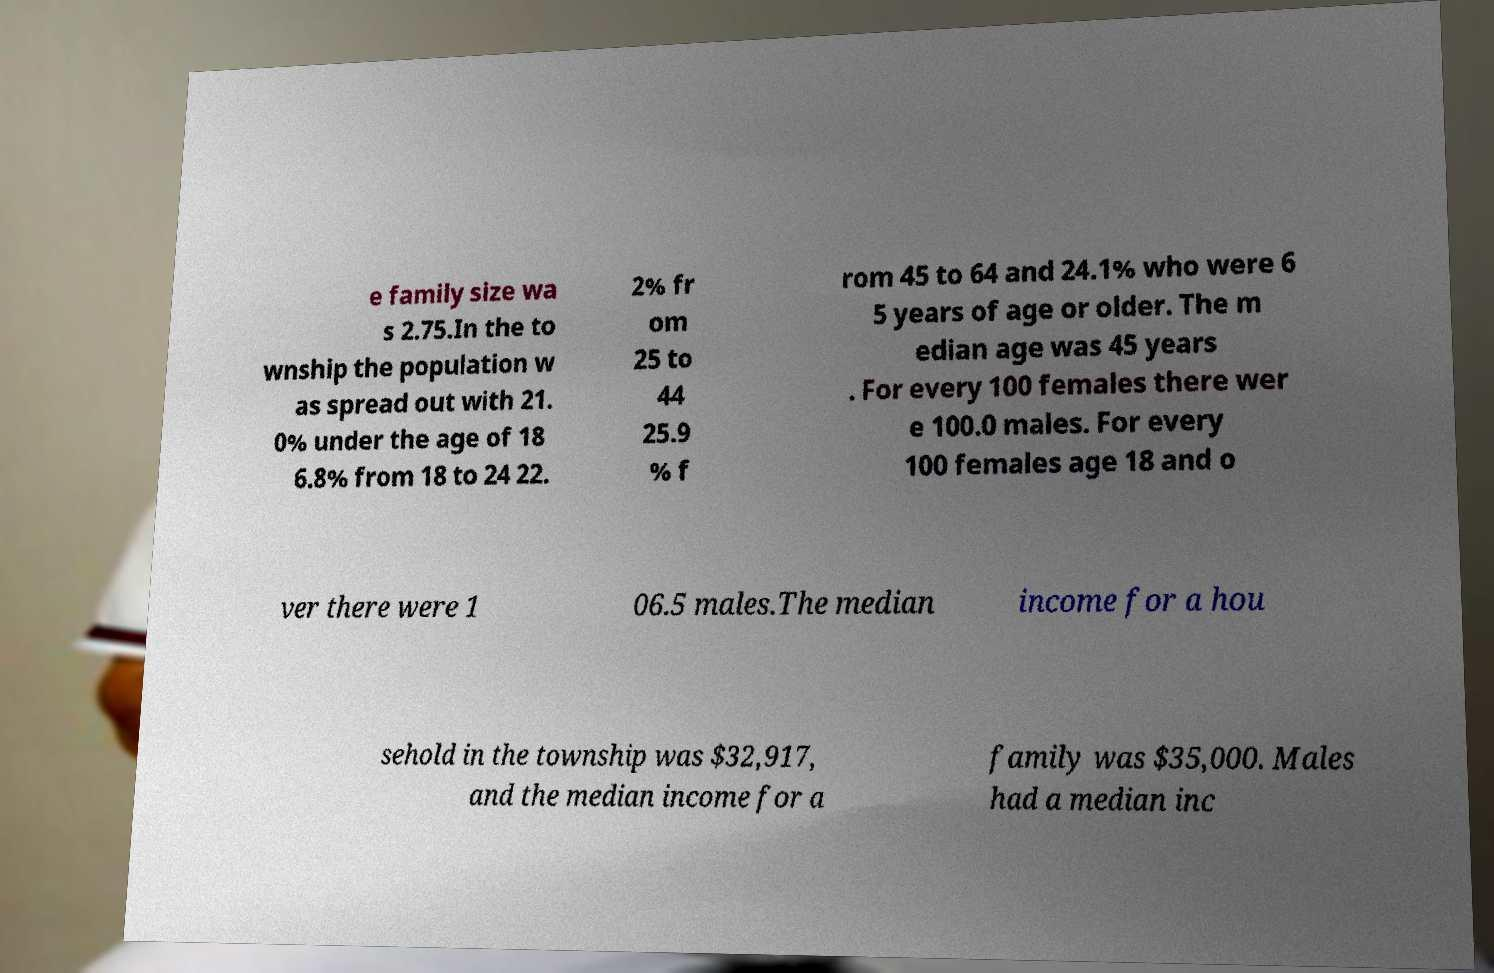Can you read and provide the text displayed in the image?This photo seems to have some interesting text. Can you extract and type it out for me? e family size wa s 2.75.In the to wnship the population w as spread out with 21. 0% under the age of 18 6.8% from 18 to 24 22. 2% fr om 25 to 44 25.9 % f rom 45 to 64 and 24.1% who were 6 5 years of age or older. The m edian age was 45 years . For every 100 females there wer e 100.0 males. For every 100 females age 18 and o ver there were 1 06.5 males.The median income for a hou sehold in the township was $32,917, and the median income for a family was $35,000. Males had a median inc 